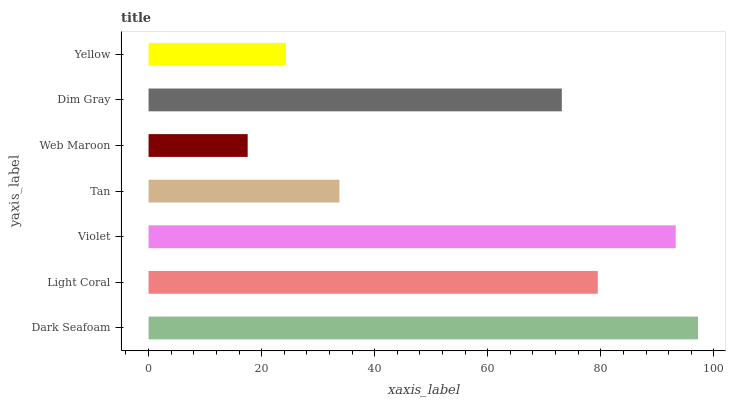Is Web Maroon the minimum?
Answer yes or no. Yes. Is Dark Seafoam the maximum?
Answer yes or no. Yes. Is Light Coral the minimum?
Answer yes or no. No. Is Light Coral the maximum?
Answer yes or no. No. Is Dark Seafoam greater than Light Coral?
Answer yes or no. Yes. Is Light Coral less than Dark Seafoam?
Answer yes or no. Yes. Is Light Coral greater than Dark Seafoam?
Answer yes or no. No. Is Dark Seafoam less than Light Coral?
Answer yes or no. No. Is Dim Gray the high median?
Answer yes or no. Yes. Is Dim Gray the low median?
Answer yes or no. Yes. Is Tan the high median?
Answer yes or no. No. Is Web Maroon the low median?
Answer yes or no. No. 